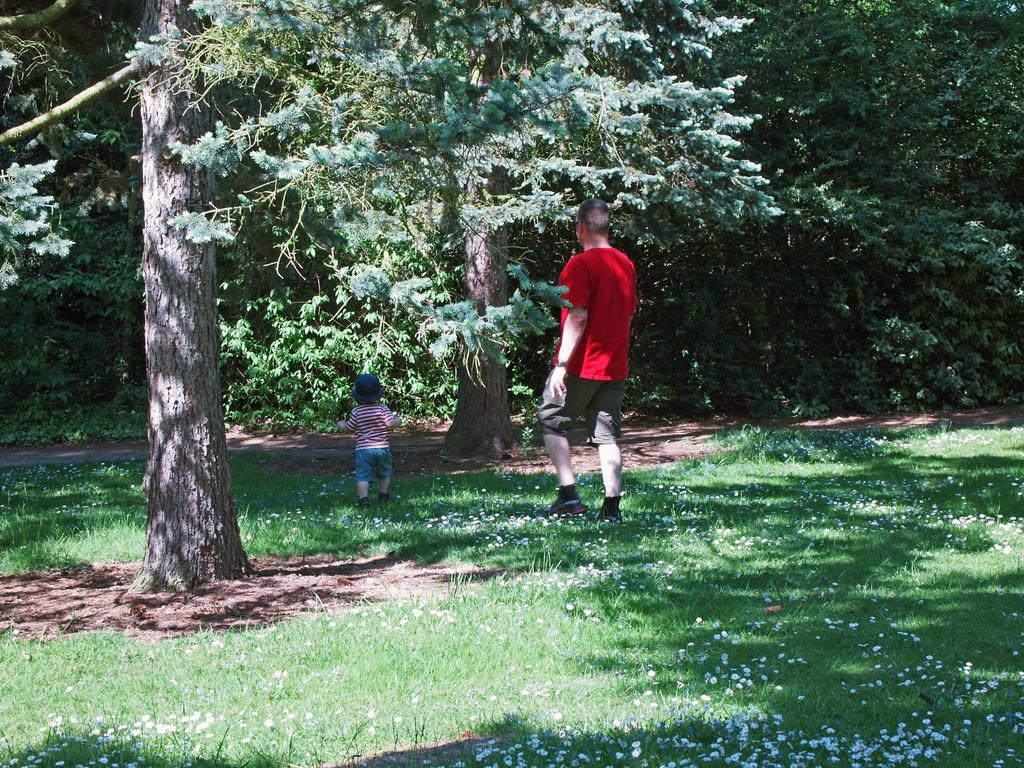Who are the two people in the foreground of the picture? There is a man and a boy in the foreground of the picture. What are the man and the boy doing in the picture? Both the man and the boy are walking on the grass. What type of vegetation can be seen in the background of the picture? There is grass, flowers, and trees visible in the background of the picture. What type of tools are the man and the boy using to fix the car in the image? There is no car or tools present in the image; it features a man and a boy walking on the grass with grass, flowers, and trees in the background. What is the relation between the man and the boy in the image? The provided facts do not give any information about the relationship between the man and the boy in the image. 